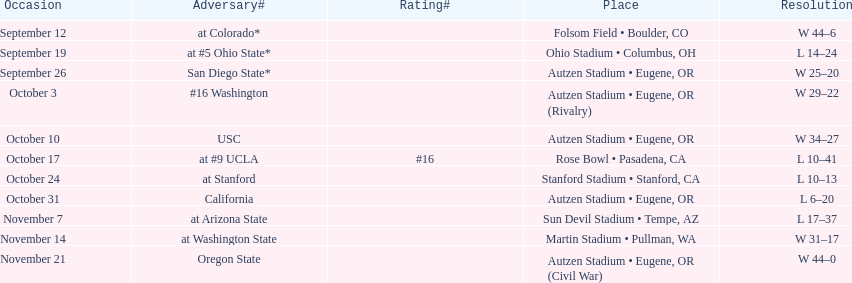Between september 26 and october 24, how many games were played in eugene, or? 3. 